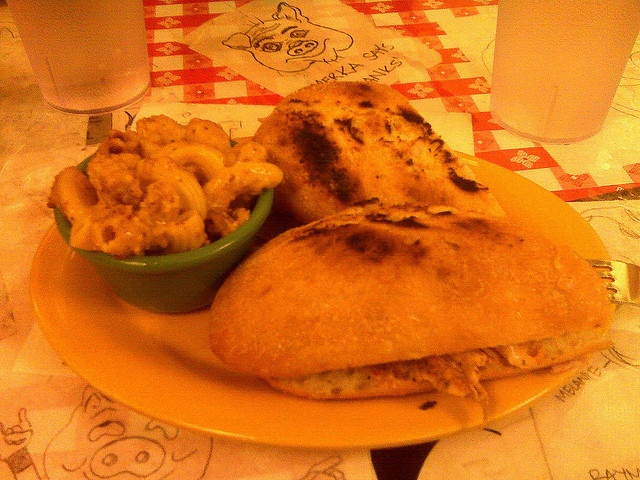Describe the objects in this image and their specific colors. I can see dining table in red, orange, and brown tones, sandwich in maroon, red, brown, and orange tones, bowl in maroon, red, and brown tones, sandwich in maroon, red, orange, and brown tones, and cup in maroon, orange, and gold tones in this image. 